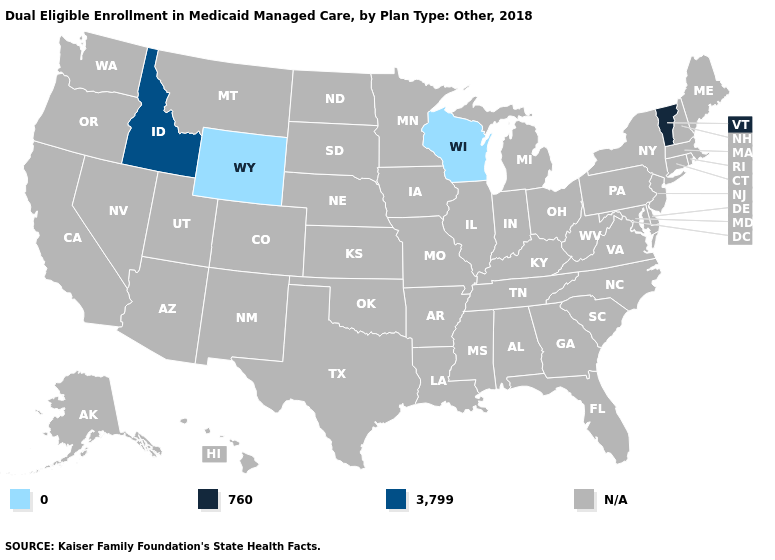What is the value of Idaho?
Write a very short answer. 3,799. Which states have the lowest value in the USA?
Quick response, please. Wisconsin, Wyoming. Which states have the lowest value in the USA?
Short answer required. Wisconsin, Wyoming. Does Idaho have the highest value in the USA?
Answer briefly. Yes. Does Idaho have the highest value in the USA?
Answer briefly. Yes. What is the highest value in the West ?
Keep it brief. 3,799. Which states hav the highest value in the MidWest?
Be succinct. Wisconsin. What is the lowest value in the USA?
Be succinct. 0. Which states have the lowest value in the USA?
Answer briefly. Wisconsin, Wyoming. Which states have the highest value in the USA?
Answer briefly. Idaho. Which states have the highest value in the USA?
Be succinct. Idaho. Name the states that have a value in the range 3,799?
Quick response, please. Idaho. What is the lowest value in the USA?
Concise answer only. 0. 